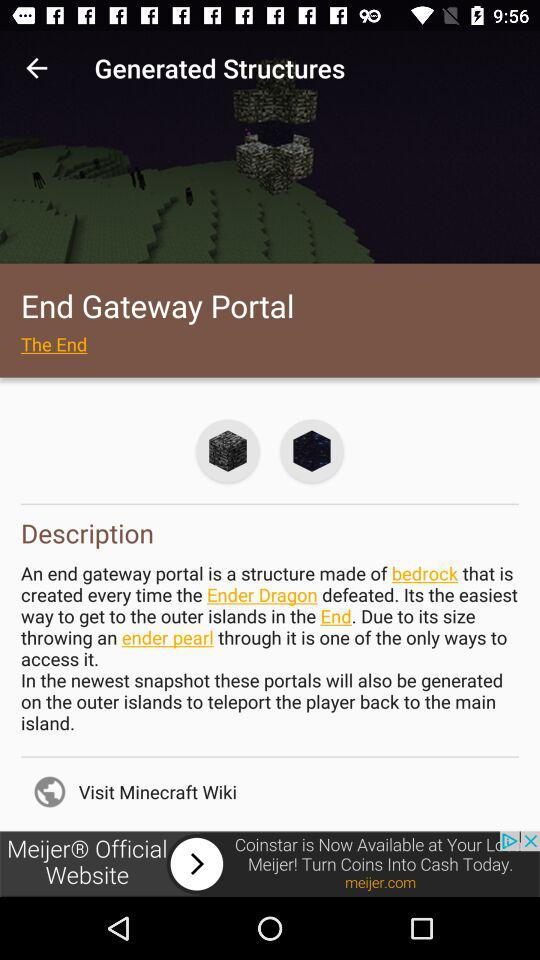What is the name of the application in the advertisement? The name of the application in the advertisement is "Meijer". 